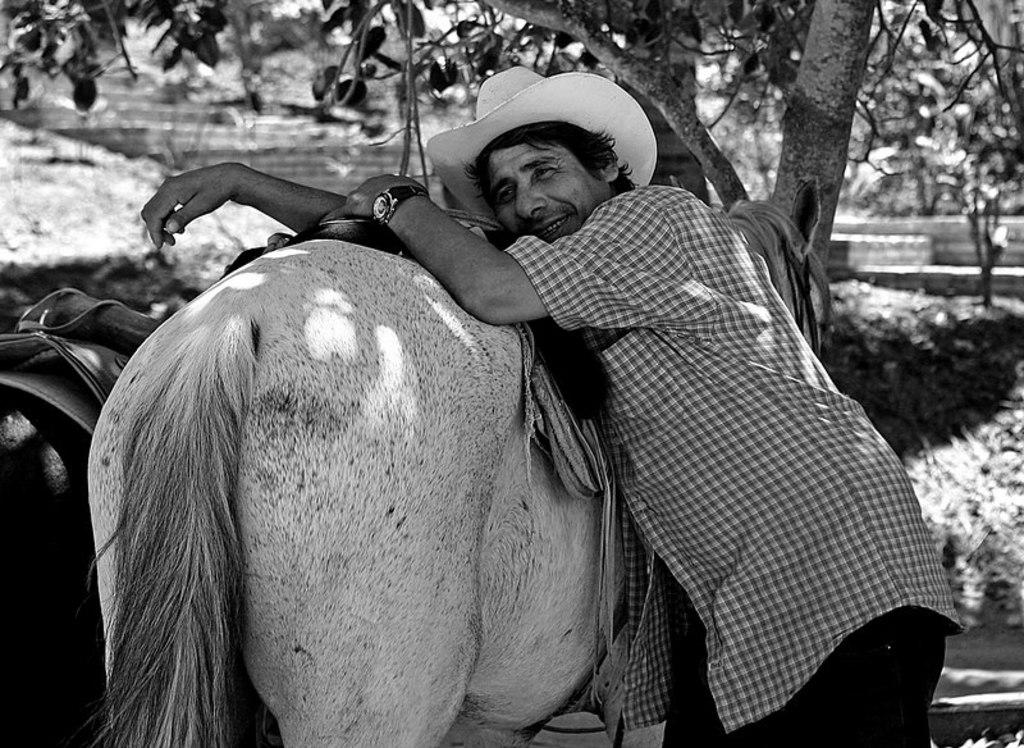Who or what is the main subject in the image? There is a person in the image. What is the person wearing on their head? The person is wearing a hat. What is the person doing in the image? The person is lying on an animal. What can be seen in the background of the image? There are visible in the background of the image. How does the person manage to keep the suit quiet in the image? There is no suit present in the image, and therefore no such action can be observed. 